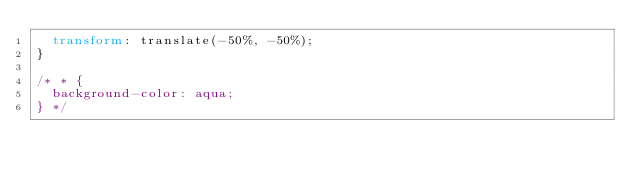Convert code to text. <code><loc_0><loc_0><loc_500><loc_500><_CSS_>  transform: translate(-50%, -50%);
}

/* * {
  background-color: aqua;
} */</code> 